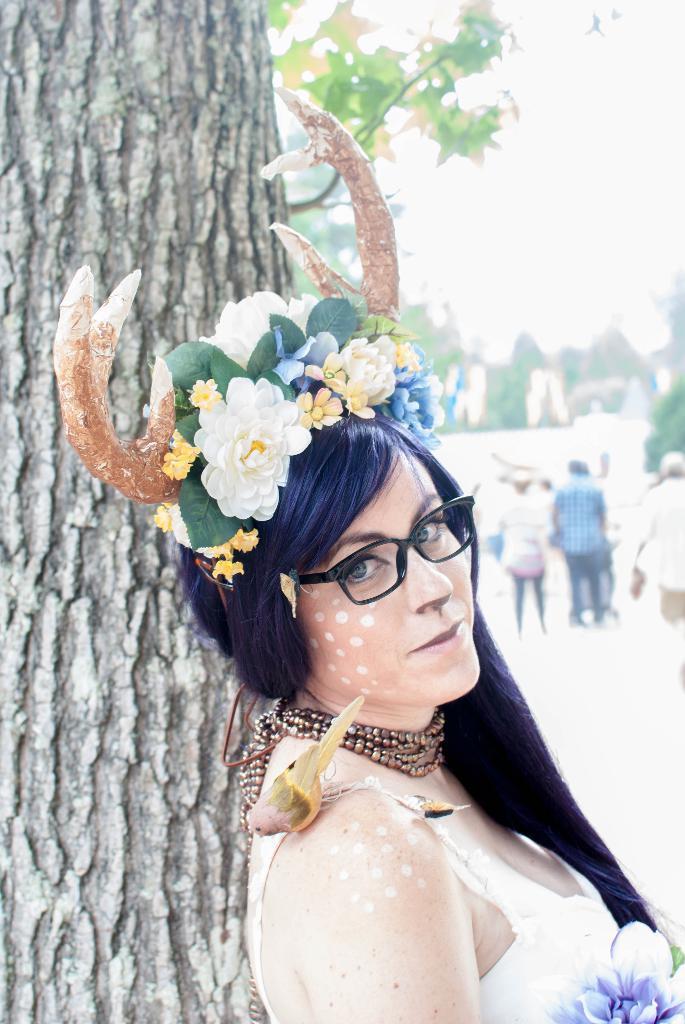How would you summarize this image in a sentence or two? In this picture there is a woman with flowers and horns. On the left side of the image there is a tree. At the back there are trees. At the top there is sky. 